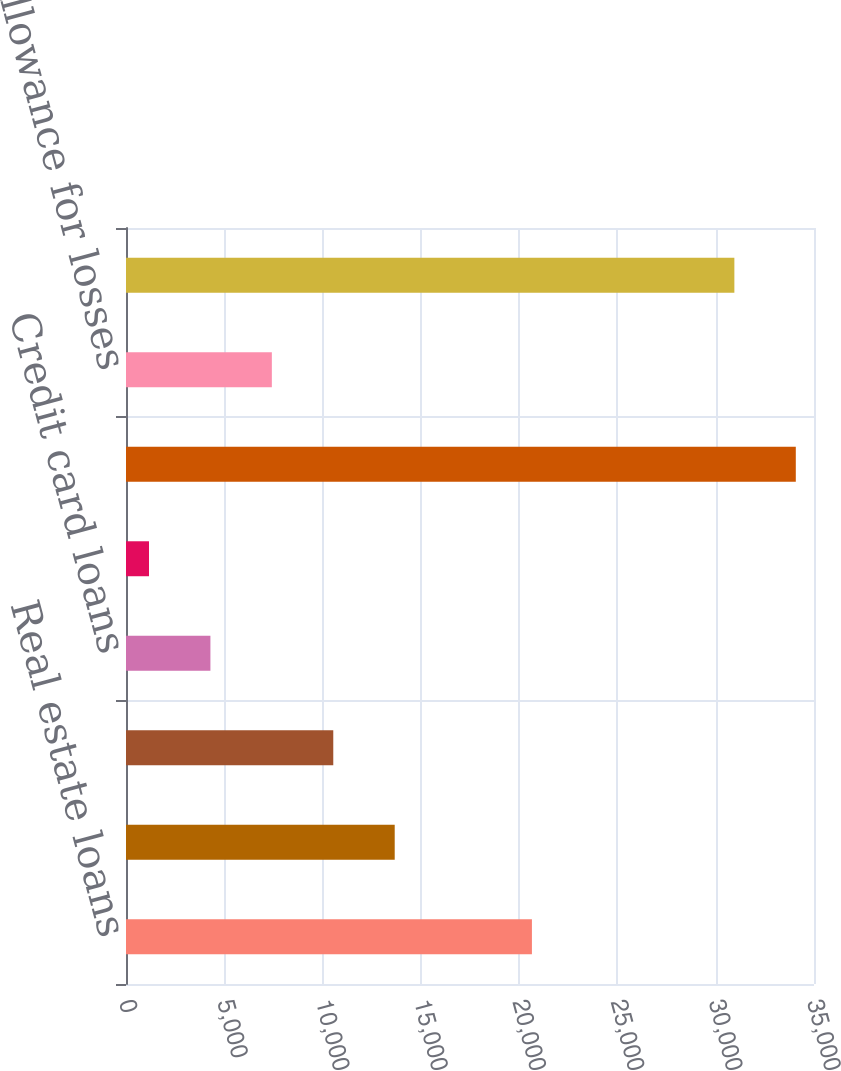Convert chart to OTSL. <chart><loc_0><loc_0><loc_500><loc_500><bar_chart><fcel>Real estate loans<fcel>Non-real estate loans<fcel>Retail sales finance<fcel>Credit card loans<fcel>Other loans<fcel>Total finance receivables<fcel>Allowance for losses<fcel>Finance receivables net<nl><fcel>20650<fcel>13669.8<fcel>10544.6<fcel>4294.2<fcel>1169<fcel>34074.2<fcel>7419.4<fcel>30949<nl></chart> 